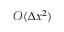<formula> <loc_0><loc_0><loc_500><loc_500>\mathcal { O } ( \Delta x ^ { 2 } )</formula> 